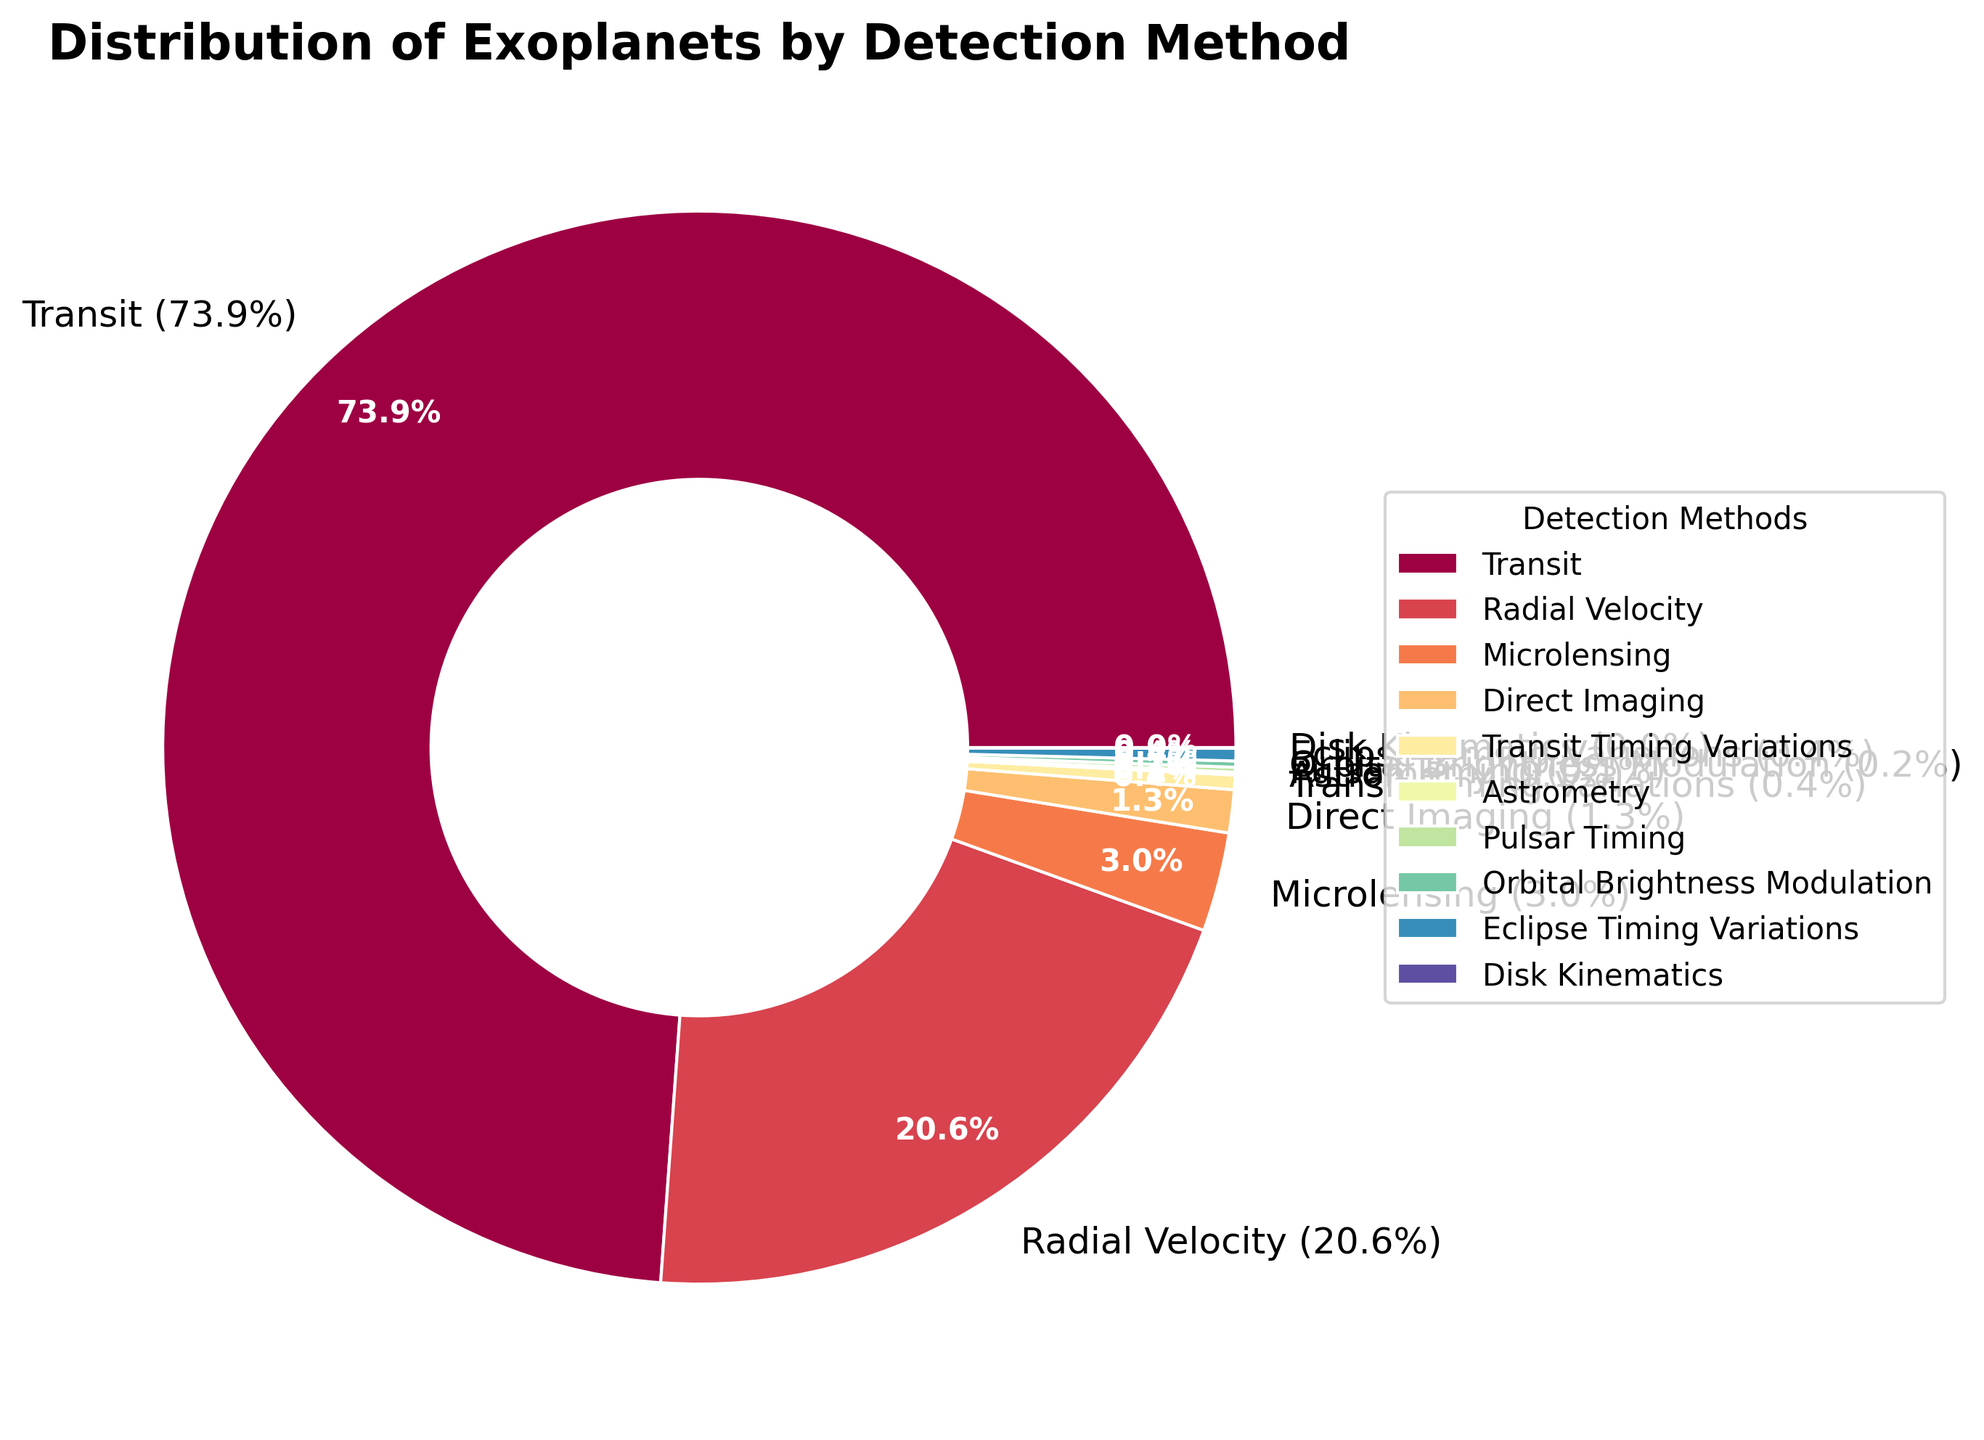Which detection method discovered the most exoplanets? By looking at the pie chart, we can see that the "Transit" method has the largest slice, which means it discovered the most exoplanets.
Answer: Transit What percentage of exoplanets were discovered using the Radial Velocity method? According to the labels on the pie chart, the Radial Velocity method accounts for 987 exoplanets, which is 17.3% of the total discoveries.
Answer: 17.3% How many exoplanets were discovered using methods other than Transit? Sum the number of exoplanets discovered by methods other than Transit: 987 (Radial Velocity) + 143 (Microlensing) + 62 (Direct Imaging) + 21 (Transit Timing Variations) + 4 (Astrometry) + 7 (Pulsar Timing) + 9 (Orbital Brightness Modulation) + 18 (Eclipse Timing Variations) + 1 (Disk Kinematics). The total is 1252.
Answer: 1252 What is the combined percentage of exoplanets discovered using Microlensing and Direct Imaging methods? Add the percentages of Microlensing and Direct Imaging from the pie chart: 2.5% (Microlensing) + 1.1% (Direct Imaging). The combined percentage is 3.6%.
Answer: 3.6% Is the number of exoplanets discovered using Eclipse Timing Variations greater than that discovered using Pulsar Timing? Compare the slices for Eclipse Timing Variations (18 exoplanets) and Pulsar Timing (7 exoplanets) on the pie chart. Since 18 is greater than 7, the number discovered using Eclipse Timing Variations is indeed greater.
Answer: Yes Which detection methods discovered fewer than 10 exoplanets each? Check the pie chart for methods with labels showing numbers fewer than 10: Orbital Brightness Modulation (9), Pulsar Timing (7), Astrometry (4), and Disk Kinematics (1).
Answer: Orbital Brightness Modulation, Pulsar Timing, Astrometry, Disk Kinematics What is the difference in the number of exoplanets discovered between Transit and Radial Velocity methods? Subtract the number of exoplanets discovered by Radial Velocity from those discovered by Transit: 3536 (Transit) - 987 (Radial Velocity) = 2549.
Answer: 2549 What proportion of exoplanets were discovered using methods that found fewer than 50 exoplanets each? Add the percentages for methods with fewer than 50 exoplanets: Astrometry (0.1%), Pulsar Timing (0.1%), Orbital Brightness Modulation (0.2%), Transit Timing Variations (0.4%), Direct Imaging (1.1%), and Disk Kinematics (0.0%). Total percentage = 1.9%.
Answer: 1.9% What is the ratio of exoplanets discovered by the Microlensing method to those discovered by Transit Timing Variations? Find the number of exoplanets for Microlensing (143) and Transit Timing Variations (21). The ratio is 143/21. Simplify the ratio: 143 ÷ 21 = 6.8.
Answer: 6.8 Name the detection method with the smallest slice on the pie chart. The smallest slice on the pie chart belongs to Disk Kinematics, which discovered only 1 exoplanet.
Answer: Disk Kinematics 